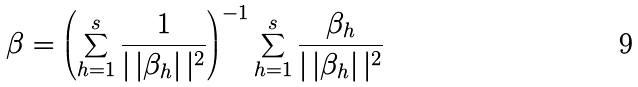Convert formula to latex. <formula><loc_0><loc_0><loc_500><loc_500>\beta = \left ( \sum _ { h = 1 } ^ { s } \frac { 1 } { | \, | \beta _ { h } | \, | ^ { 2 } } \right ) ^ { - 1 } \sum _ { h = 1 } ^ { s } \frac { \beta _ { h } } { | \, | \beta _ { h } | \, | ^ { 2 } }</formula> 